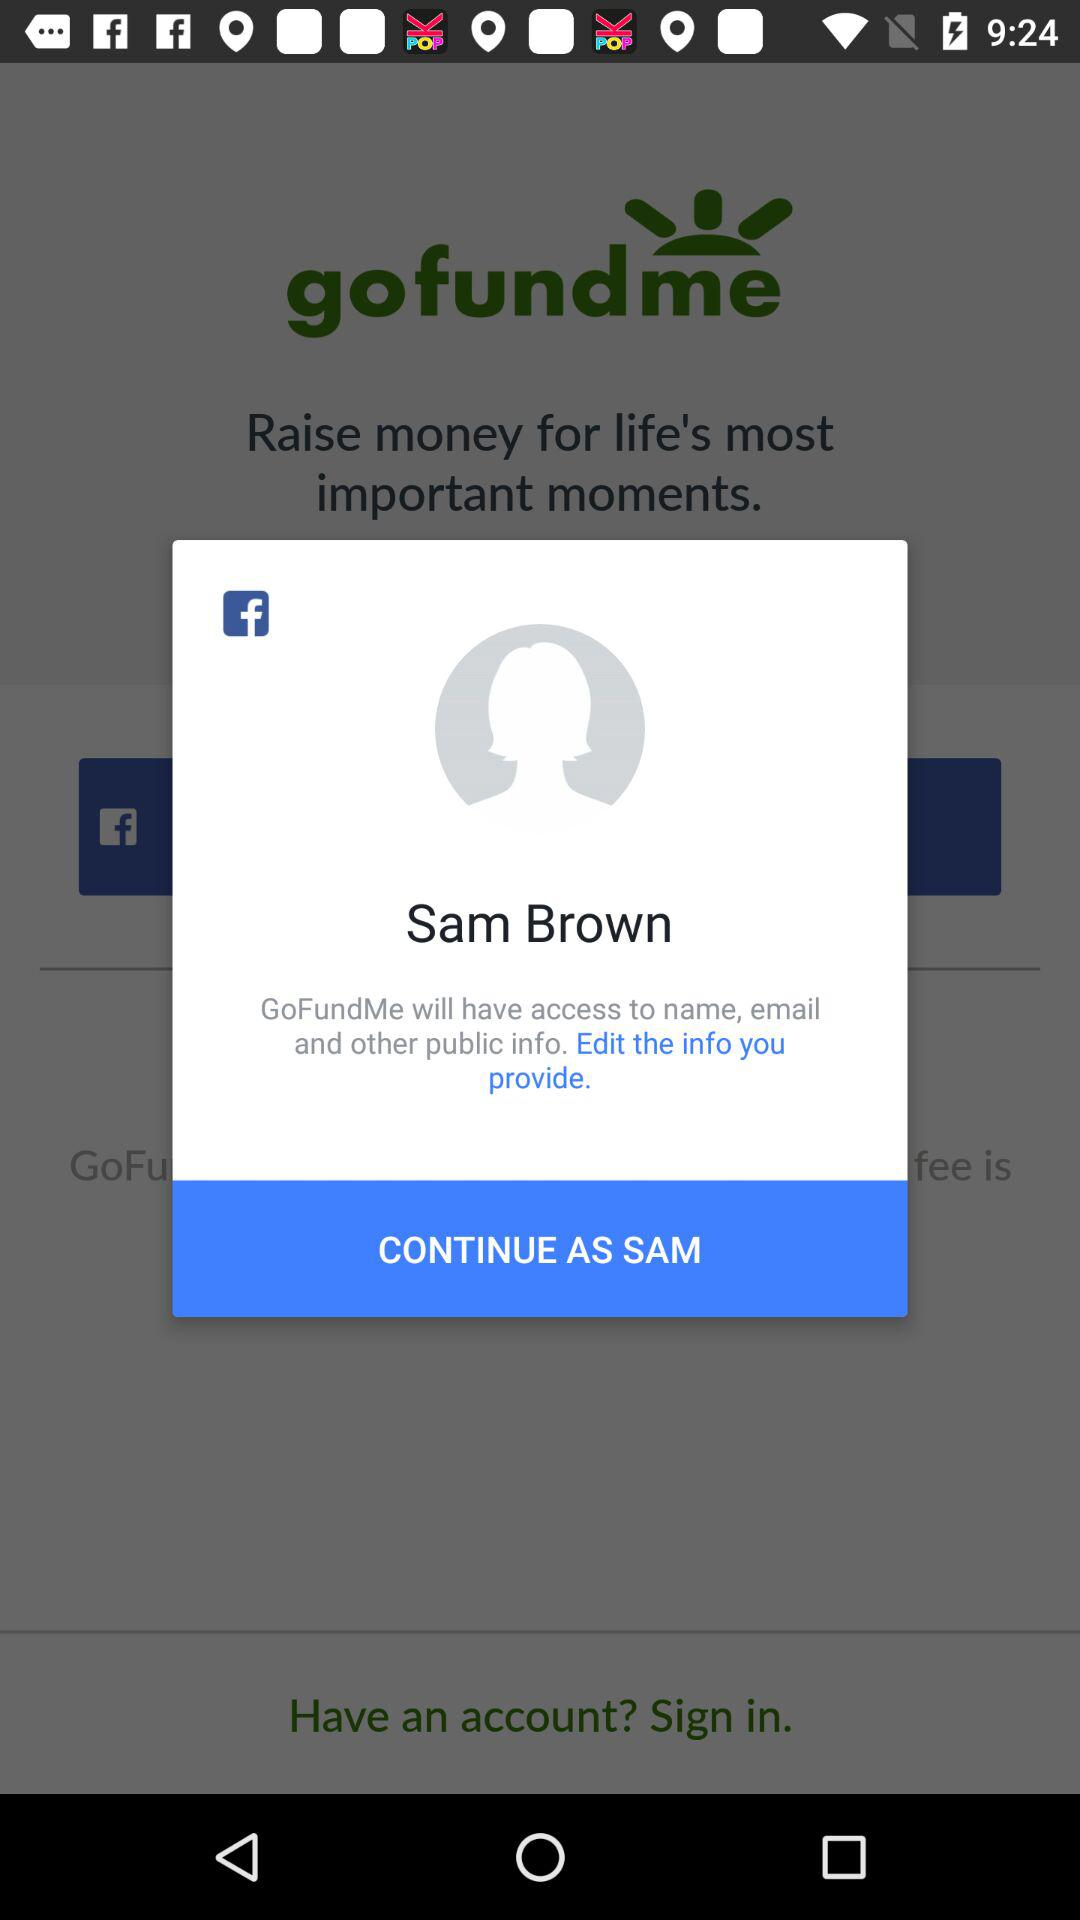How old is Sam Brown?
When the provided information is insufficient, respond with <no answer>. <no answer> 